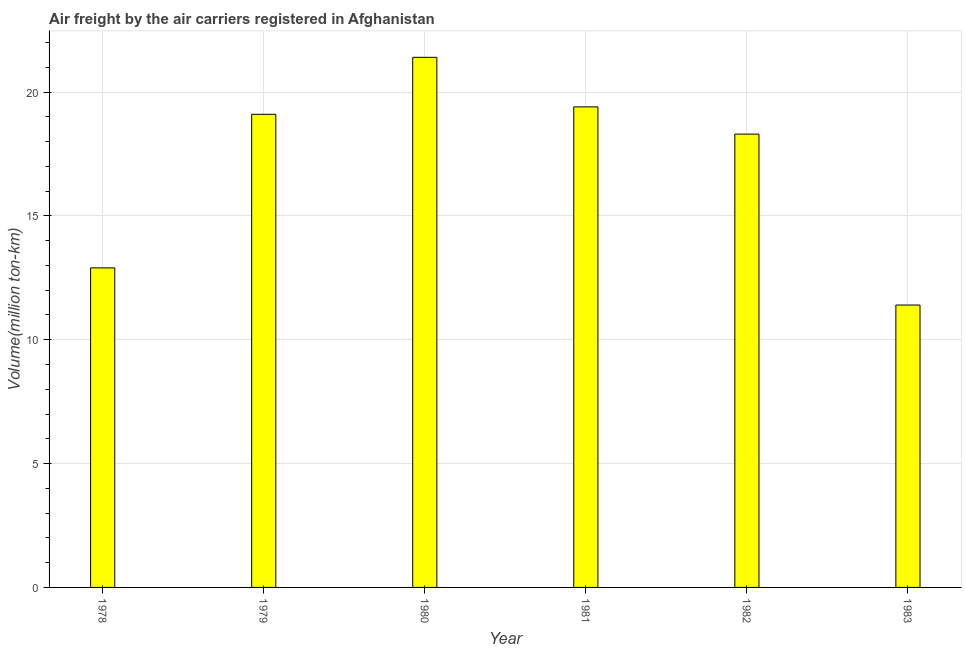Does the graph contain any zero values?
Provide a short and direct response. No. Does the graph contain grids?
Your answer should be compact. Yes. What is the title of the graph?
Provide a succinct answer. Air freight by the air carriers registered in Afghanistan. What is the label or title of the Y-axis?
Keep it short and to the point. Volume(million ton-km). What is the air freight in 1982?
Provide a short and direct response. 18.3. Across all years, what is the maximum air freight?
Ensure brevity in your answer.  21.4. Across all years, what is the minimum air freight?
Make the answer very short. 11.4. In which year was the air freight minimum?
Your answer should be compact. 1983. What is the sum of the air freight?
Keep it short and to the point. 102.5. What is the average air freight per year?
Provide a succinct answer. 17.08. What is the median air freight?
Offer a very short reply. 18.7. Do a majority of the years between 1982 and 1981 (inclusive) have air freight greater than 18 million ton-km?
Your response must be concise. No. What is the ratio of the air freight in 1980 to that in 1982?
Provide a short and direct response. 1.17. Is the difference between the air freight in 1978 and 1983 greater than the difference between any two years?
Offer a terse response. No. Is the sum of the air freight in 1979 and 1983 greater than the maximum air freight across all years?
Give a very brief answer. Yes. How many bars are there?
Your answer should be compact. 6. What is the Volume(million ton-km) in 1978?
Make the answer very short. 12.9. What is the Volume(million ton-km) of 1979?
Your answer should be very brief. 19.1. What is the Volume(million ton-km) of 1980?
Keep it short and to the point. 21.4. What is the Volume(million ton-km) of 1981?
Provide a succinct answer. 19.4. What is the Volume(million ton-km) of 1982?
Keep it short and to the point. 18.3. What is the Volume(million ton-km) of 1983?
Provide a short and direct response. 11.4. What is the difference between the Volume(million ton-km) in 1979 and 1982?
Ensure brevity in your answer.  0.8. What is the difference between the Volume(million ton-km) in 1979 and 1983?
Provide a succinct answer. 7.7. What is the difference between the Volume(million ton-km) in 1980 and 1981?
Keep it short and to the point. 2. What is the difference between the Volume(million ton-km) in 1980 and 1982?
Ensure brevity in your answer.  3.1. What is the difference between the Volume(million ton-km) in 1981 and 1982?
Your answer should be compact. 1.1. What is the ratio of the Volume(million ton-km) in 1978 to that in 1979?
Your answer should be compact. 0.68. What is the ratio of the Volume(million ton-km) in 1978 to that in 1980?
Your response must be concise. 0.6. What is the ratio of the Volume(million ton-km) in 1978 to that in 1981?
Give a very brief answer. 0.67. What is the ratio of the Volume(million ton-km) in 1978 to that in 1982?
Offer a very short reply. 0.7. What is the ratio of the Volume(million ton-km) in 1978 to that in 1983?
Provide a short and direct response. 1.13. What is the ratio of the Volume(million ton-km) in 1979 to that in 1980?
Your answer should be compact. 0.89. What is the ratio of the Volume(million ton-km) in 1979 to that in 1982?
Offer a very short reply. 1.04. What is the ratio of the Volume(million ton-km) in 1979 to that in 1983?
Provide a succinct answer. 1.68. What is the ratio of the Volume(million ton-km) in 1980 to that in 1981?
Provide a succinct answer. 1.1. What is the ratio of the Volume(million ton-km) in 1980 to that in 1982?
Ensure brevity in your answer.  1.17. What is the ratio of the Volume(million ton-km) in 1980 to that in 1983?
Offer a very short reply. 1.88. What is the ratio of the Volume(million ton-km) in 1981 to that in 1982?
Your response must be concise. 1.06. What is the ratio of the Volume(million ton-km) in 1981 to that in 1983?
Your response must be concise. 1.7. What is the ratio of the Volume(million ton-km) in 1982 to that in 1983?
Keep it short and to the point. 1.6. 